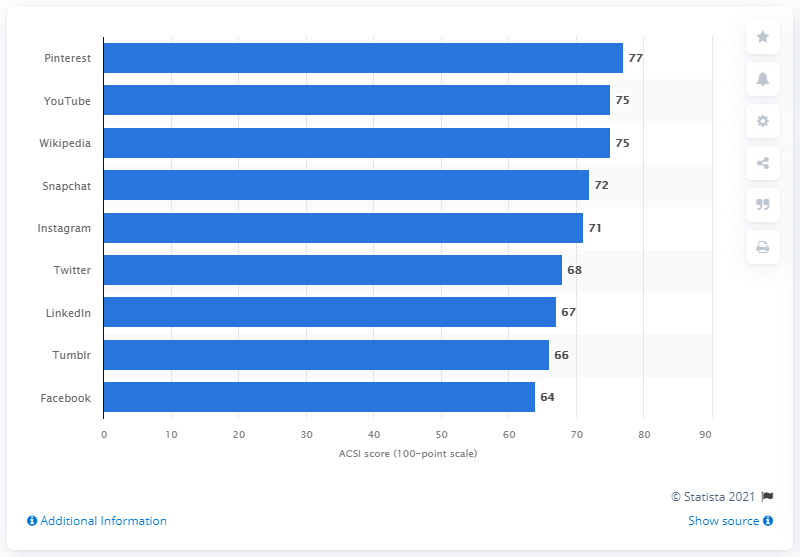Mention a couple of crucial points in this snapshot. As of now, Pinterest has 77 index points. 